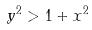Convert formula to latex. <formula><loc_0><loc_0><loc_500><loc_500>y ^ { 2 } > 1 + x ^ { 2 }</formula> 